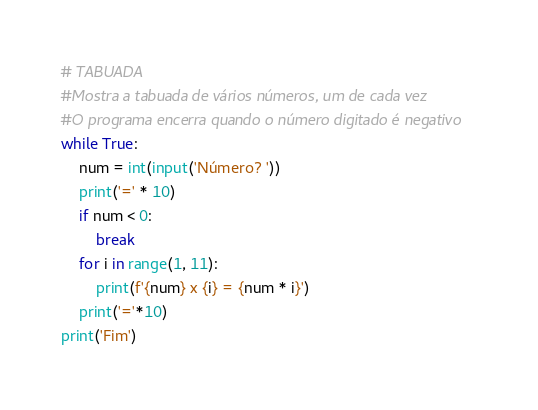Convert code to text. <code><loc_0><loc_0><loc_500><loc_500><_Python_># TABUADA
#Mostra a tabuada de vários números, um de cada vez
#O programa encerra quando o número digitado é negativo
while True:
    num = int(input('Número? '))
    print('=' * 10)
    if num < 0:
        break
    for i in range(1, 11):
        print(f'{num} x {i} = {num * i}')
    print('='*10)
print('Fim')</code> 